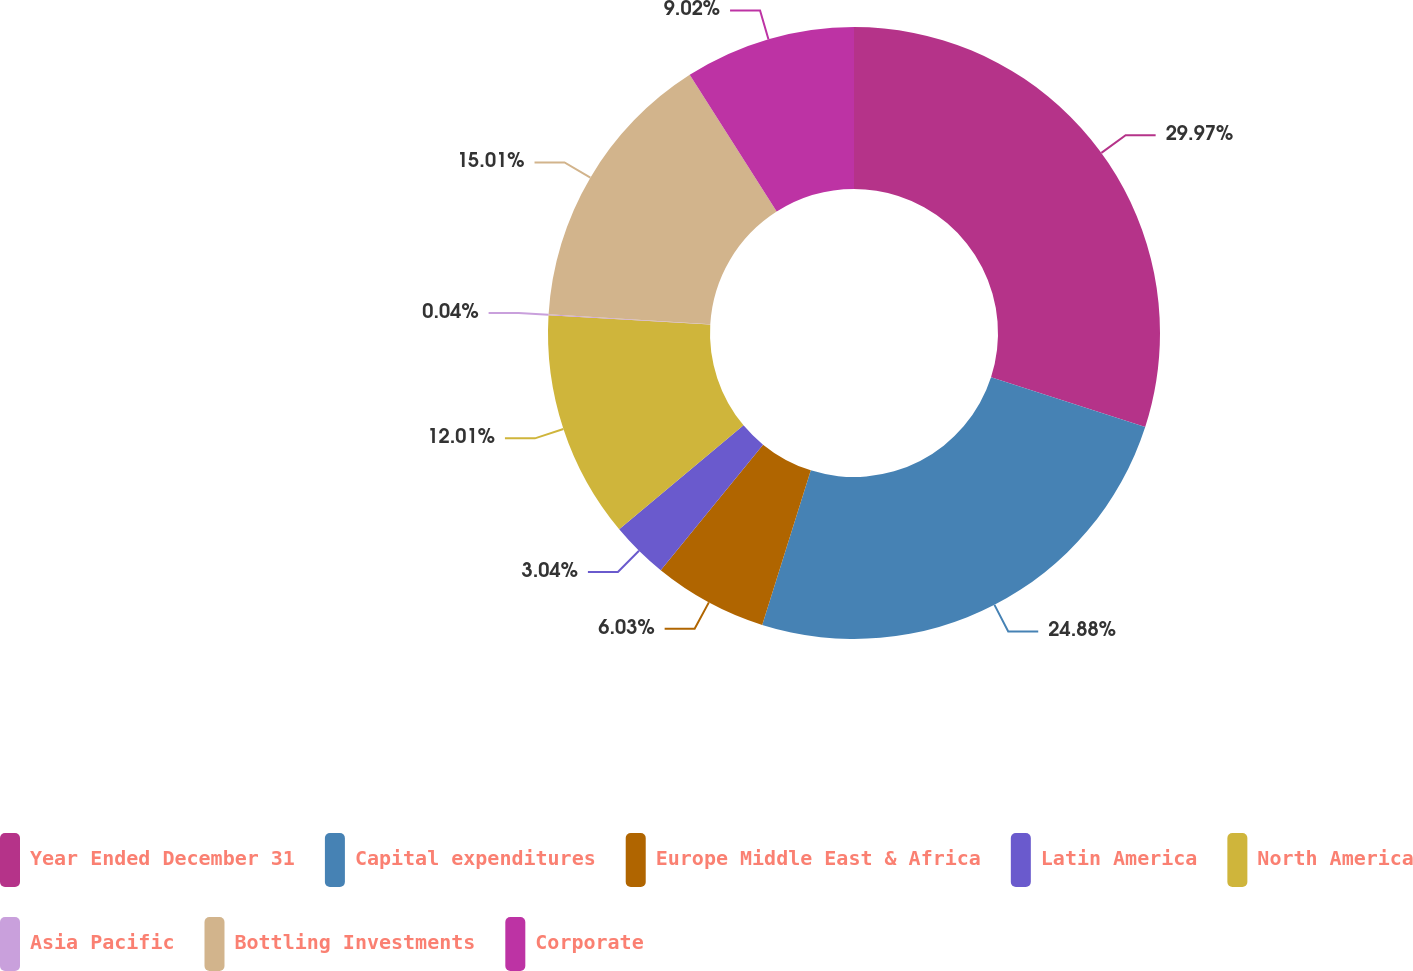Convert chart. <chart><loc_0><loc_0><loc_500><loc_500><pie_chart><fcel>Year Ended December 31<fcel>Capital expenditures<fcel>Europe Middle East & Africa<fcel>Latin America<fcel>North America<fcel>Asia Pacific<fcel>Bottling Investments<fcel>Corporate<nl><fcel>29.97%<fcel>24.88%<fcel>6.03%<fcel>3.04%<fcel>12.01%<fcel>0.04%<fcel>15.01%<fcel>9.02%<nl></chart> 